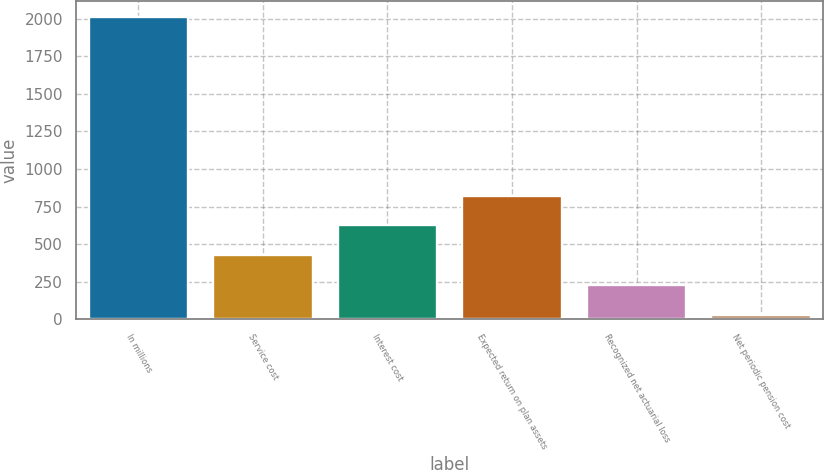<chart> <loc_0><loc_0><loc_500><loc_500><bar_chart><fcel>In millions<fcel>Service cost<fcel>Interest cost<fcel>Expected return on plan assets<fcel>Recognized net actuarial loss<fcel>Net periodic pension cost<nl><fcel>2016<fcel>424.8<fcel>623.7<fcel>822.6<fcel>225.9<fcel>27<nl></chart> 